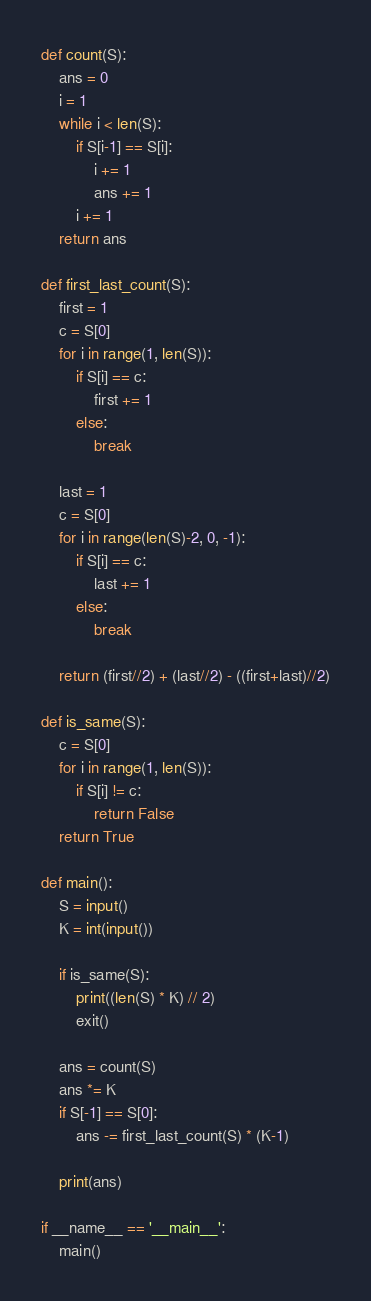<code> <loc_0><loc_0><loc_500><loc_500><_Python_>def count(S):
    ans = 0
    i = 1
    while i < len(S):
        if S[i-1] == S[i]:
            i += 1
            ans += 1
        i += 1
    return ans

def first_last_count(S):
    first = 1
    c = S[0]
    for i in range(1, len(S)):
        if S[i] == c:
            first += 1
        else:
            break

    last = 1
    c = S[0]
    for i in range(len(S)-2, 0, -1):
        if S[i] == c:
            last += 1
        else:
            break

    return (first//2) + (last//2) - ((first+last)//2)

def is_same(S):
    c = S[0]
    for i in range(1, len(S)):
        if S[i] != c:
            return False
    return True

def main():
    S = input()
    K = int(input())

    if is_same(S):
        print((len(S) * K) // 2)
        exit()

    ans = count(S)
    ans *= K
    if S[-1] == S[0]:
        ans -= first_last_count(S) * (K-1)

    print(ans)

if __name__ == '__main__':
    main()</code> 